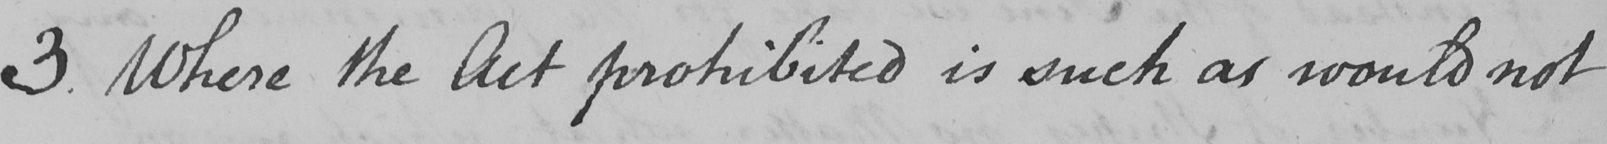Please provide the text content of this handwritten line. 3 . Where the Act prohibited is such as would not 